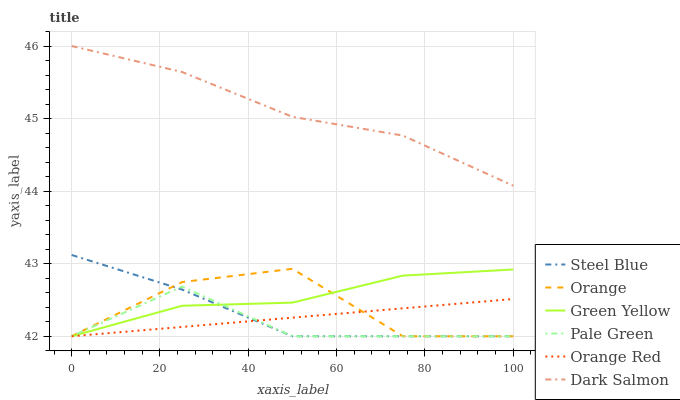Does Pale Green have the minimum area under the curve?
Answer yes or no. Yes. Does Dark Salmon have the maximum area under the curve?
Answer yes or no. Yes. Does Steel Blue have the minimum area under the curve?
Answer yes or no. No. Does Steel Blue have the maximum area under the curve?
Answer yes or no. No. Is Orange Red the smoothest?
Answer yes or no. Yes. Is Orange the roughest?
Answer yes or no. Yes. Is Steel Blue the smoothest?
Answer yes or no. No. Is Steel Blue the roughest?
Answer yes or no. No. Does Dark Salmon have the highest value?
Answer yes or no. Yes. Does Steel Blue have the highest value?
Answer yes or no. No. Is Steel Blue less than Dark Salmon?
Answer yes or no. Yes. Is Dark Salmon greater than Steel Blue?
Answer yes or no. Yes. Does Green Yellow intersect Orange?
Answer yes or no. Yes. Is Green Yellow less than Orange?
Answer yes or no. No. Is Green Yellow greater than Orange?
Answer yes or no. No. Does Steel Blue intersect Dark Salmon?
Answer yes or no. No. 